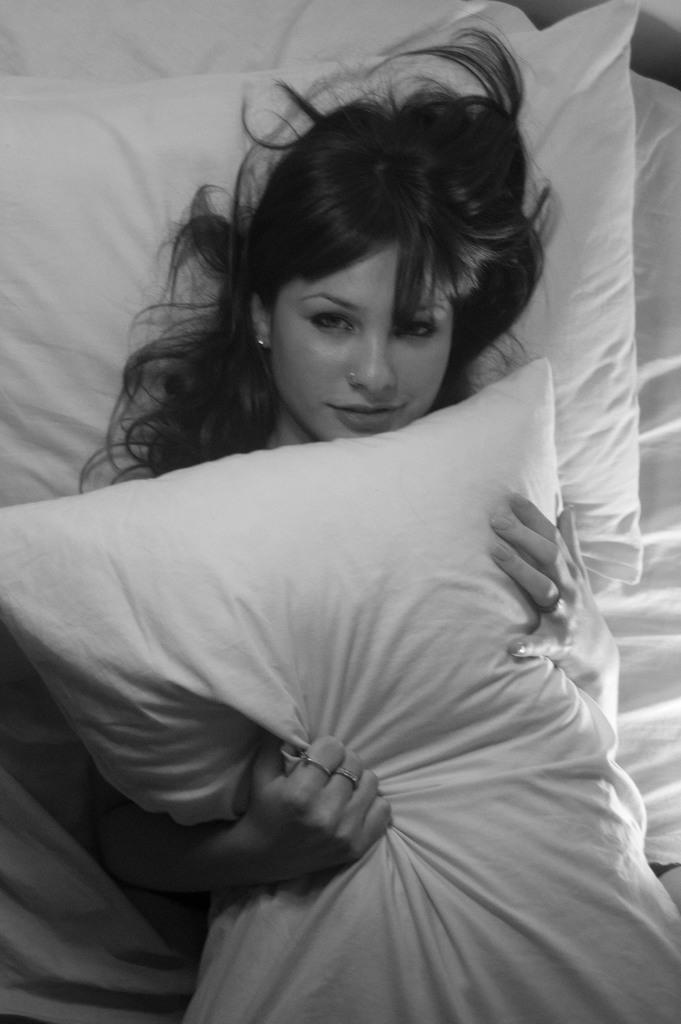What is the color scheme of the image? The image is black and white. Who is present in the image? There is a woman in the image. What is the woman doing in the image? The woman is lying on a bed. What object is the woman holding in the image? The woman is holding a pillow. What type of spark can be seen coming from the pillow in the image? There is no spark present in the image; it is a black and white image of a woman lying on a bed and holding a pillow. 